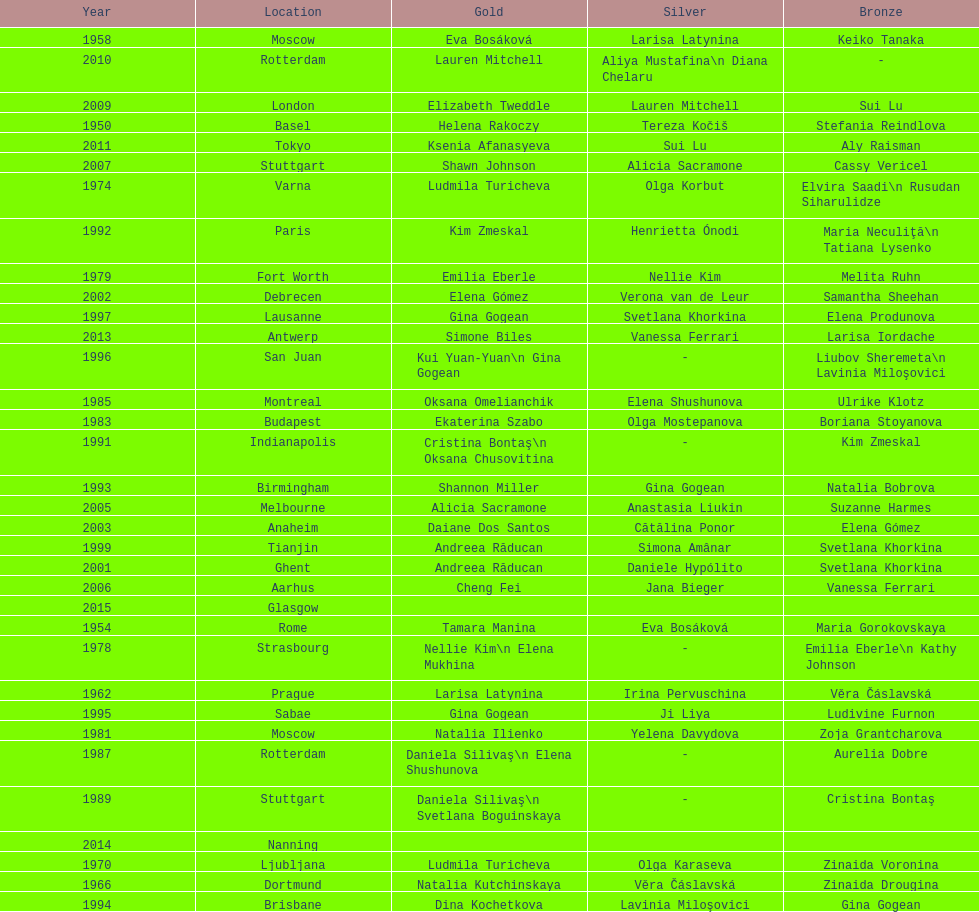What is the total number of russian gymnasts that have won silver. 8. Can you give me this table as a dict? {'header': ['Year', 'Location', 'Gold', 'Silver', 'Bronze'], 'rows': [['1958', 'Moscow', 'Eva Bosáková', 'Larisa Latynina', 'Keiko Tanaka'], ['2010', 'Rotterdam', 'Lauren Mitchell', 'Aliya Mustafina\\n Diana Chelaru', '-'], ['2009', 'London', 'Elizabeth Tweddle', 'Lauren Mitchell', 'Sui Lu'], ['1950', 'Basel', 'Helena Rakoczy', 'Tereza Kočiš', 'Stefania Reindlova'], ['2011', 'Tokyo', 'Ksenia Afanasyeva', 'Sui Lu', 'Aly Raisman'], ['2007', 'Stuttgart', 'Shawn Johnson', 'Alicia Sacramone', 'Cassy Vericel'], ['1974', 'Varna', 'Ludmila Turicheva', 'Olga Korbut', 'Elvira Saadi\\n Rusudan Siharulidze'], ['1992', 'Paris', 'Kim Zmeskal', 'Henrietta Ónodi', 'Maria Neculiţă\\n Tatiana Lysenko'], ['1979', 'Fort Worth', 'Emilia Eberle', 'Nellie Kim', 'Melita Ruhn'], ['2002', 'Debrecen', 'Elena Gómez', 'Verona van de Leur', 'Samantha Sheehan'], ['1997', 'Lausanne', 'Gina Gogean', 'Svetlana Khorkina', 'Elena Produnova'], ['2013', 'Antwerp', 'Simone Biles', 'Vanessa Ferrari', 'Larisa Iordache'], ['1996', 'San Juan', 'Kui Yuan-Yuan\\n Gina Gogean', '-', 'Liubov Sheremeta\\n Lavinia Miloşovici'], ['1985', 'Montreal', 'Oksana Omelianchik', 'Elena Shushunova', 'Ulrike Klotz'], ['1983', 'Budapest', 'Ekaterina Szabo', 'Olga Mostepanova', 'Boriana Stoyanova'], ['1991', 'Indianapolis', 'Cristina Bontaş\\n Oksana Chusovitina', '-', 'Kim Zmeskal'], ['1993', 'Birmingham', 'Shannon Miller', 'Gina Gogean', 'Natalia Bobrova'], ['2005', 'Melbourne', 'Alicia Sacramone', 'Anastasia Liukin', 'Suzanne Harmes'], ['2003', 'Anaheim', 'Daiane Dos Santos', 'Cătălina Ponor', 'Elena Gómez'], ['1999', 'Tianjin', 'Andreea Răducan', 'Simona Amânar', 'Svetlana Khorkina'], ['2001', 'Ghent', 'Andreea Răducan', 'Daniele Hypólito', 'Svetlana Khorkina'], ['2006', 'Aarhus', 'Cheng Fei', 'Jana Bieger', 'Vanessa Ferrari'], ['2015', 'Glasgow', '', '', ''], ['1954', 'Rome', 'Tamara Manina', 'Eva Bosáková', 'Maria Gorokovskaya'], ['1978', 'Strasbourg', 'Nellie Kim\\n Elena Mukhina', '-', 'Emilia Eberle\\n Kathy Johnson'], ['1962', 'Prague', 'Larisa Latynina', 'Irina Pervuschina', 'Věra Čáslavská'], ['1995', 'Sabae', 'Gina Gogean', 'Ji Liya', 'Ludivine Furnon'], ['1981', 'Moscow', 'Natalia Ilienko', 'Yelena Davydova', 'Zoja Grantcharova'], ['1987', 'Rotterdam', 'Daniela Silivaş\\n Elena Shushunova', '-', 'Aurelia Dobre'], ['1989', 'Stuttgart', 'Daniela Silivaş\\n Svetlana Boguinskaya', '-', 'Cristina Bontaş'], ['2014', 'Nanning', '', '', ''], ['1970', 'Ljubljana', 'Ludmila Turicheva', 'Olga Karaseva', 'Zinaida Voronina'], ['1966', 'Dortmund', 'Natalia Kutchinskaya', 'Věra Čáslavská', 'Zinaida Drougina'], ['1994', 'Brisbane', 'Dina Kochetkova', 'Lavinia Miloşovici', 'Gina Gogean']]} 